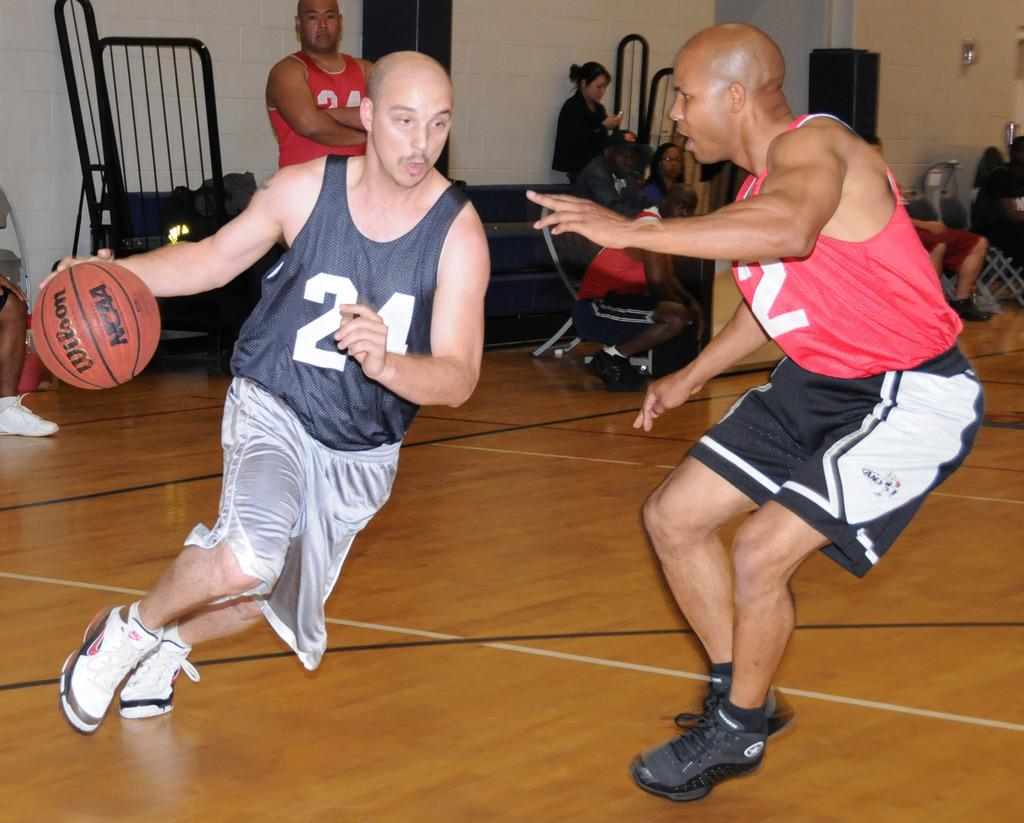<image>
Provide a brief description of the given image. Both basketball players have a 2 on their jerseys. 